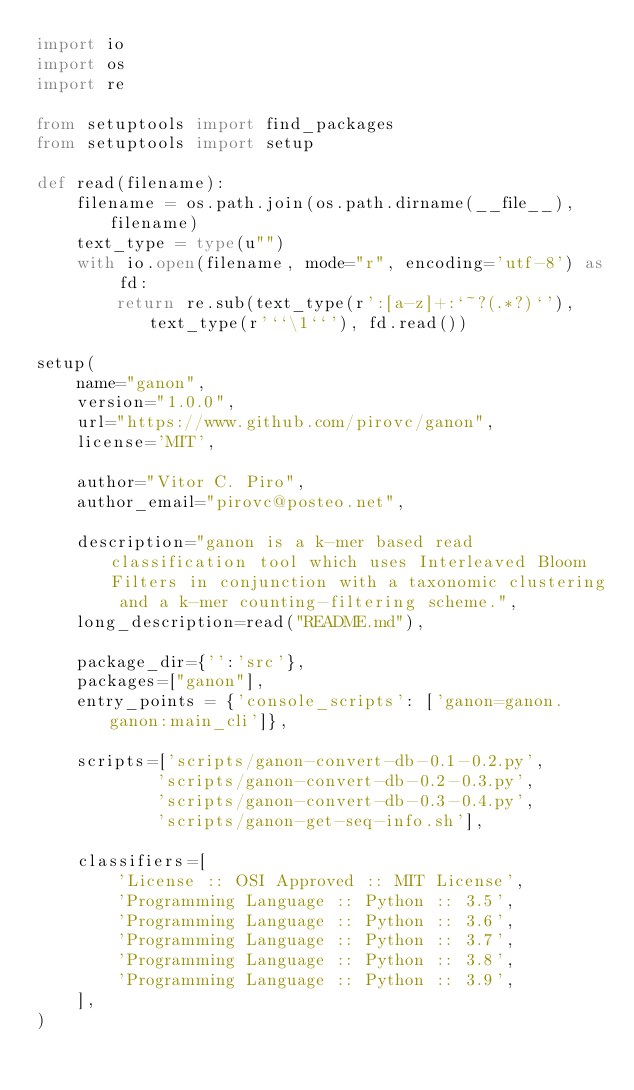<code> <loc_0><loc_0><loc_500><loc_500><_Python_>import io
import os
import re

from setuptools import find_packages
from setuptools import setup

def read(filename):
    filename = os.path.join(os.path.dirname(__file__), filename)
    text_type = type(u"")
    with io.open(filename, mode="r", encoding='utf-8') as fd:
        return re.sub(text_type(r':[a-z]+:`~?(.*?)`'), text_type(r'``\1``'), fd.read())

setup(
    name="ganon",
    version="1.0.0",
    url="https://www.github.com/pirovc/ganon",
    license='MIT',

    author="Vitor C. Piro",
    author_email="pirovc@posteo.net",    

    description="ganon is a k-mer based read classification tool which uses Interleaved Bloom Filters in conjunction with a taxonomic clustering and a k-mer counting-filtering scheme.",
    long_description=read("README.md"),

    package_dir={'':'src'},
    packages=["ganon"],
    entry_points = {'console_scripts': ['ganon=ganon.ganon:main_cli']},
    
    scripts=['scripts/ganon-convert-db-0.1-0.2.py',
            'scripts/ganon-convert-db-0.2-0.3.py',
            'scripts/ganon-convert-db-0.3-0.4.py',
            'scripts/ganon-get-seq-info.sh'],

    classifiers=[
        'License :: OSI Approved :: MIT License',
        'Programming Language :: Python :: 3.5',
        'Programming Language :: Python :: 3.6',
        'Programming Language :: Python :: 3.7',
        'Programming Language :: Python :: 3.8',
        'Programming Language :: Python :: 3.9',
    ],
)
</code> 